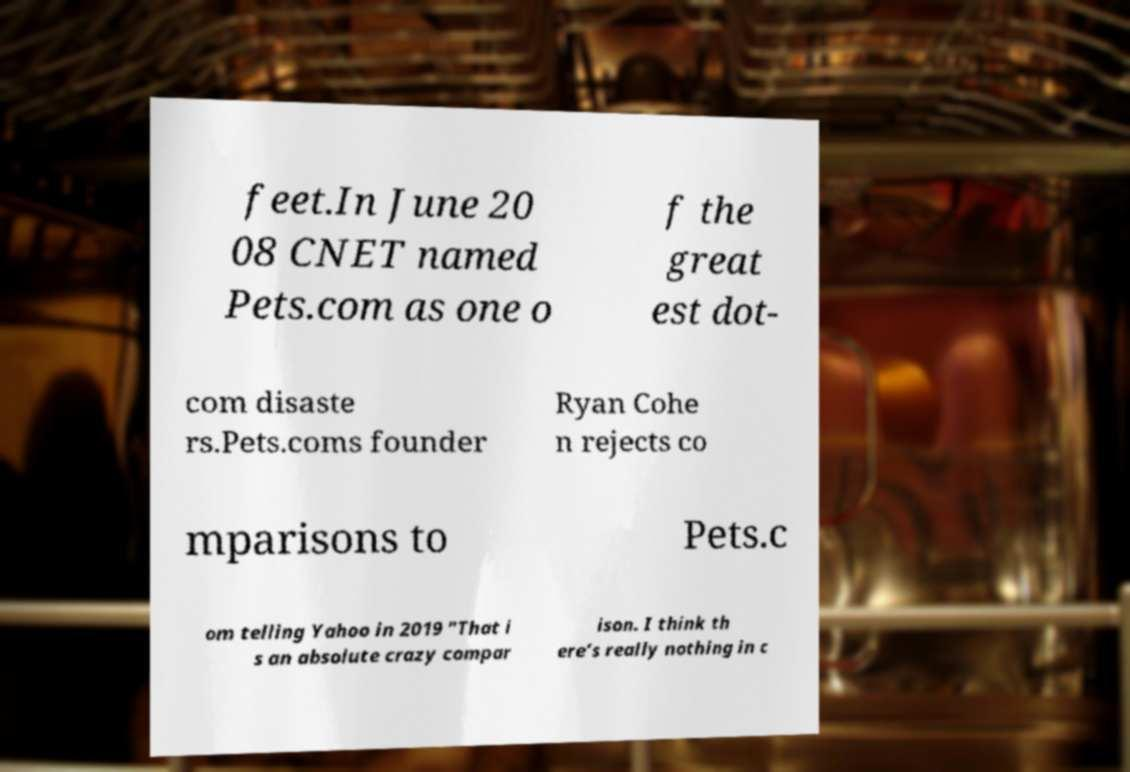For documentation purposes, I need the text within this image transcribed. Could you provide that? feet.In June 20 08 CNET named Pets.com as one o f the great est dot- com disaste rs.Pets.coms founder Ryan Cohe n rejects co mparisons to Pets.c om telling Yahoo in 2019 "That i s an absolute crazy compar ison. I think th ere’s really nothing in c 